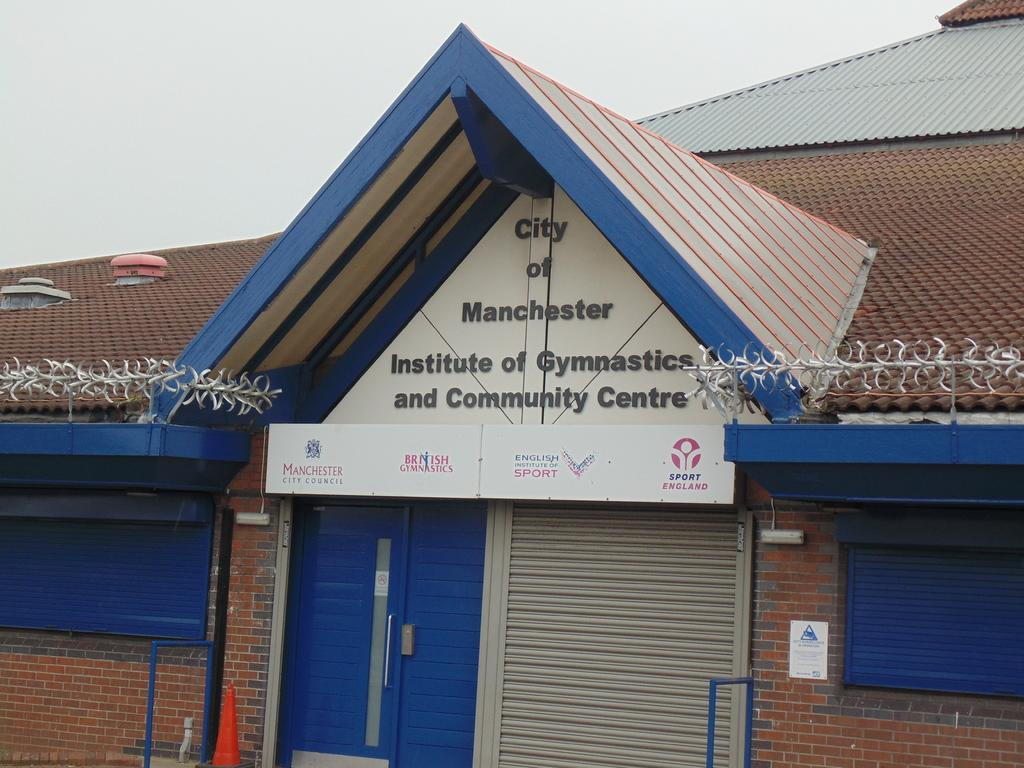What type of facility is shown in the image? The image depicts a gymnastic center. What activities might be taking place at this facility? Gymnastics-related activities, such as practicing routines, using equipment, and training, might be taking place at this facility. Can you describe any specific features of the gymnastic center in the image? Unfortunately, the provided facts do not include any specific features of the gymnastic center. How many marks can be seen on the zebra in the image? There is no zebra present in the image, so it is not possible to determine the number of marks on a zebra. 